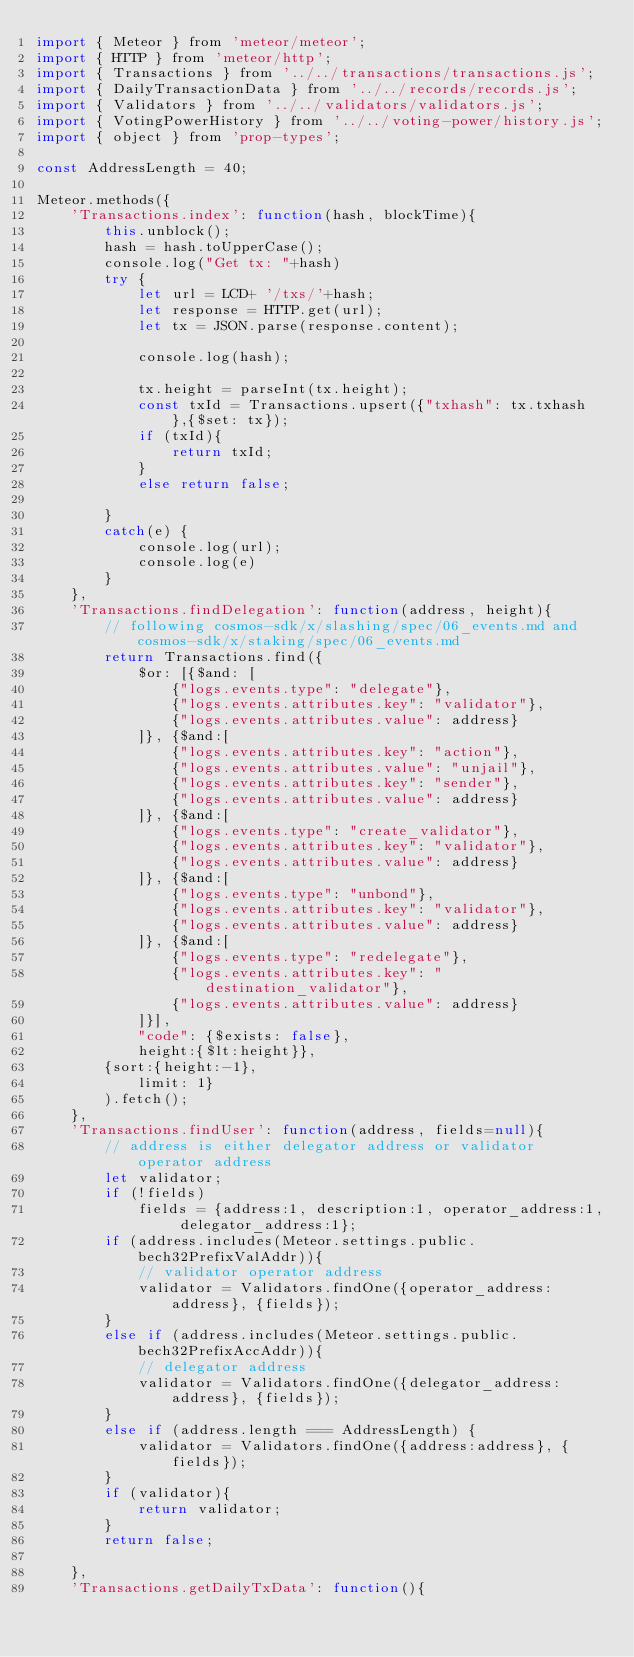Convert code to text. <code><loc_0><loc_0><loc_500><loc_500><_JavaScript_>import { Meteor } from 'meteor/meteor';
import { HTTP } from 'meteor/http';
import { Transactions } from '../../transactions/transactions.js';
import { DailyTransactionData } from '../../records/records.js';
import { Validators } from '../../validators/validators.js';
import { VotingPowerHistory } from '../../voting-power/history.js';
import { object } from 'prop-types';

const AddressLength = 40;

Meteor.methods({
    'Transactions.index': function(hash, blockTime){
        this.unblock();
        hash = hash.toUpperCase();
        console.log("Get tx: "+hash)
        try {
            let url = LCD+ '/txs/'+hash;
            let response = HTTP.get(url);
            let tx = JSON.parse(response.content);
    
            console.log(hash);
    
            tx.height = parseInt(tx.height);
            const txId = Transactions.upsert({"txhash": tx.txhash},{$set: tx});
            if (txId){
                return txId;
            }
            else return false;
    
        }
        catch(e) {
            console.log(url);
            console.log(e)
        }
    },
    'Transactions.findDelegation': function(address, height){
        // following cosmos-sdk/x/slashing/spec/06_events.md and cosmos-sdk/x/staking/spec/06_events.md
        return Transactions.find({
            $or: [{$and: [
                {"logs.events.type": "delegate"},
                {"logs.events.attributes.key": "validator"},
                {"logs.events.attributes.value": address}
            ]}, {$and:[
                {"logs.events.attributes.key": "action"},
                {"logs.events.attributes.value": "unjail"},
                {"logs.events.attributes.key": "sender"},
                {"logs.events.attributes.value": address}
            ]}, {$and:[
                {"logs.events.type": "create_validator"},
                {"logs.events.attributes.key": "validator"},
                {"logs.events.attributes.value": address}
            ]}, {$and:[
                {"logs.events.type": "unbond"},
                {"logs.events.attributes.key": "validator"},
                {"logs.events.attributes.value": address}
            ]}, {$and:[
                {"logs.events.type": "redelegate"},
                {"logs.events.attributes.key": "destination_validator"},
                {"logs.events.attributes.value": address}
            ]}],
            "code": {$exists: false},
            height:{$lt:height}},
        {sort:{height:-1},
            limit: 1}
        ).fetch();
    },
    'Transactions.findUser': function(address, fields=null){
        // address is either delegator address or validator operator address
        let validator;
        if (!fields)
            fields = {address:1, description:1, operator_address:1, delegator_address:1};
        if (address.includes(Meteor.settings.public.bech32PrefixValAddr)){
            // validator operator address
            validator = Validators.findOne({operator_address:address}, {fields});
        }
        else if (address.includes(Meteor.settings.public.bech32PrefixAccAddr)){
            // delegator address
            validator = Validators.findOne({delegator_address:address}, {fields});
        }
        else if (address.length === AddressLength) {
            validator = Validators.findOne({address:address}, {fields});
        }
        if (validator){
            return validator;
        }
        return false;

    },
    'Transactions.getDailyTxData': function(){</code> 